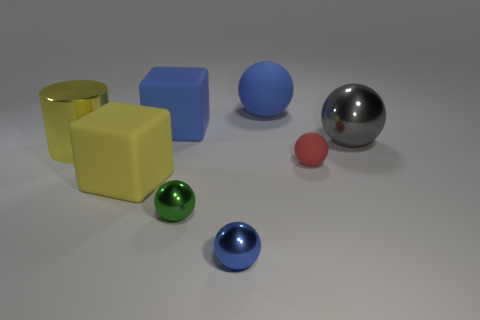Are there the same number of large cylinders to the right of the yellow block and blue objects right of the small red rubber thing?
Ensure brevity in your answer.  Yes. Does the yellow rubber object have the same size as the blue thing that is on the right side of the blue shiny thing?
Ensure brevity in your answer.  Yes. Are there more big yellow matte objects behind the large blue matte block than large blue rubber spheres?
Your answer should be compact. No. What number of green metal things have the same size as the red sphere?
Offer a very short reply. 1. Does the block on the right side of the yellow rubber thing have the same size as the shiny thing left of the yellow matte block?
Provide a succinct answer. Yes. Is the number of things right of the big shiny sphere greater than the number of large cylinders that are on the right side of the blue metal sphere?
Keep it short and to the point. No. What number of large blue objects are the same shape as the green metallic thing?
Make the answer very short. 1. What material is the yellow block that is the same size as the cylinder?
Keep it short and to the point. Rubber. Are there any red spheres made of the same material as the small green thing?
Your answer should be very brief. No. Are there fewer large yellow cubes that are in front of the small green metal object than big blue rubber objects?
Offer a very short reply. Yes. 